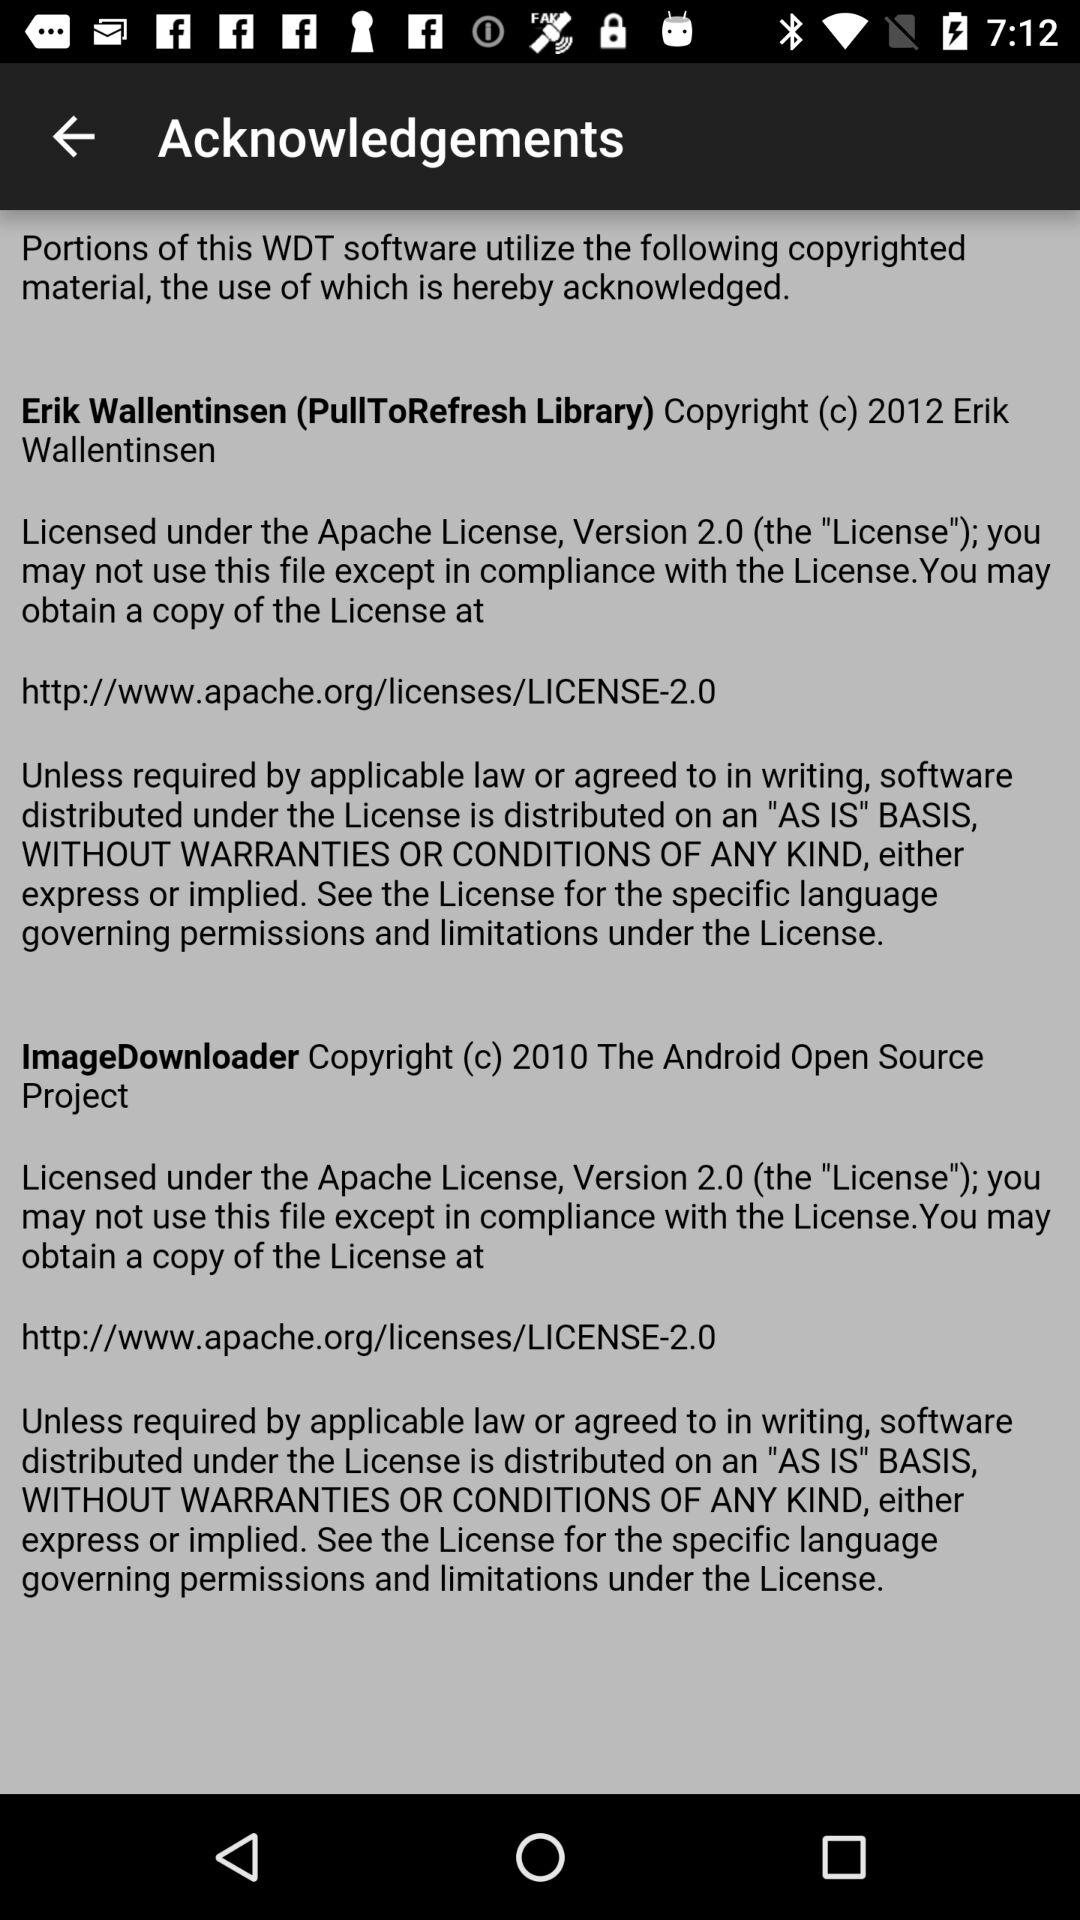What Apache license version does Erik Wallentinsen have? Erik Wallentinsen has an Apache license version 2.0. 